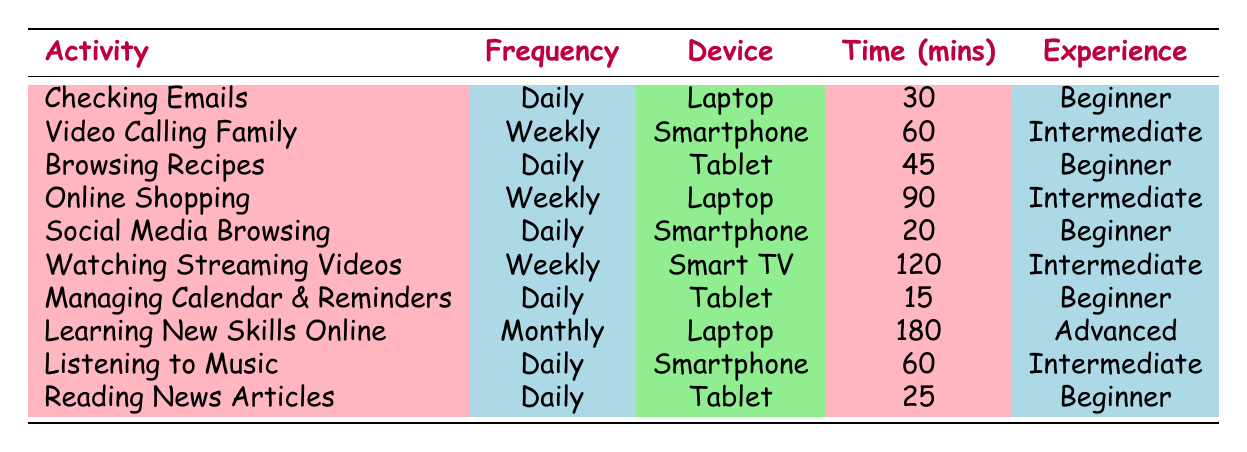What device is used for video calling family? The table lists the activity "Video Calling Family" under the "Device" column, which shows that the device used is "Smartphone."
Answer: Smartphone How many minutes are spent on reading news articles? According to the table, the activity "Reading News Articles" has a time spent of 25 minutes listed under the "Time (mins)" column.
Answer: 25 minutes What is the average time spent on daily activities? The daily activities include "Checking Emails" (30), "Browsing Recipes" (45), "Social Media Browsing" (20), "Managing Calendar & Reminders" (15), "Listening to Music" (60), and "Reading News Articles" (25). Summing these gives 30 + 45 + 20 + 15 + 60 + 25 = 195 minutes. There are 6 daily activities, so the average is 195 / 6 = 32.5 minutes.
Answer: 32.5 minutes Is online shopping an activity that occurs daily? The table indicates that "Online Shopping" has a frequency of "Weekly," therefore it does not occur daily.
Answer: No Which activity has the highest time spent? By examining the "Time (mins)" column, "Watching Streaming Videos" has the highest time spent at 120 minutes, which is greater than any other activity listed in the table.
Answer: 120 minutes 